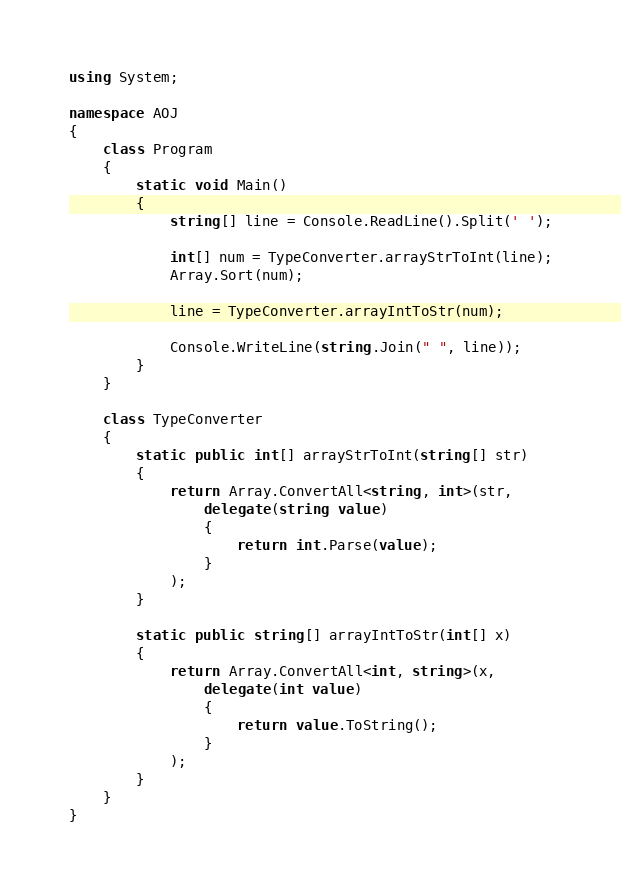<code> <loc_0><loc_0><loc_500><loc_500><_C#_>using System;

namespace AOJ
{
    class Program
    {
        static void Main()
        {
            string[] line = Console.ReadLine().Split(' ');

            int[] num = TypeConverter.arrayStrToInt(line);
            Array.Sort(num);

            line = TypeConverter.arrayIntToStr(num);

            Console.WriteLine(string.Join(" ", line));
        }
    }

    class TypeConverter
    {
        static public int[] arrayStrToInt(string[] str)
        {
            return Array.ConvertAll<string, int>(str,
                delegate(string value)
                {
                    return int.Parse(value);
                }
            );
        }

        static public string[] arrayIntToStr(int[] x)
        {
            return Array.ConvertAll<int, string>(x,
                delegate(int value)
                {
                    return value.ToString();
                }
            );
        }
    }
}</code> 